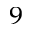<formula> <loc_0><loc_0><loc_500><loc_500>^ { 9 }</formula> 